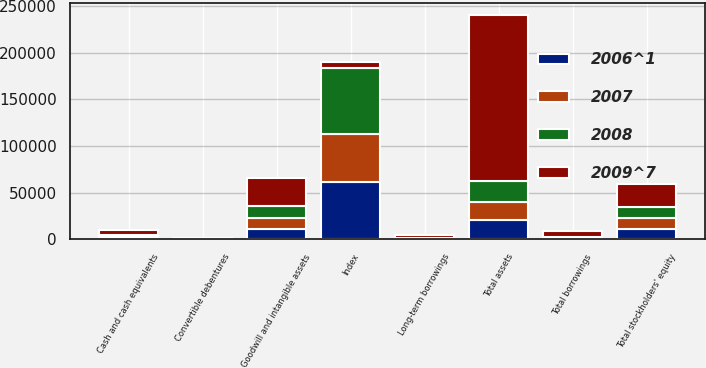<chart> <loc_0><loc_0><loc_500><loc_500><stacked_bar_chart><ecel><fcel>Cash and cash equivalents<fcel>Goodwill and intangible assets<fcel>Total assets<fcel>Convertible debentures<fcel>Long-term borrowings<fcel>Total borrowings<fcel>Total stockholders' equity<fcel>Index<nl><fcel>2009^7<fcel>4708<fcel>30218<fcel>177994<fcel>243<fcel>3191<fcel>5668<fcel>24329<fcel>5668<nl><fcel>2007<fcel>2032<fcel>11974<fcel>19924<fcel>245<fcel>697<fcel>1142<fcel>12069<fcel>51076<nl><fcel>2008<fcel>1656<fcel>12073<fcel>22561<fcel>242<fcel>697<fcel>1239<fcel>11601<fcel>71381<nl><fcel>2006^1<fcel>1160<fcel>11139<fcel>20470<fcel>238<fcel>3<fcel>241<fcel>10789<fcel>61631<nl></chart> 